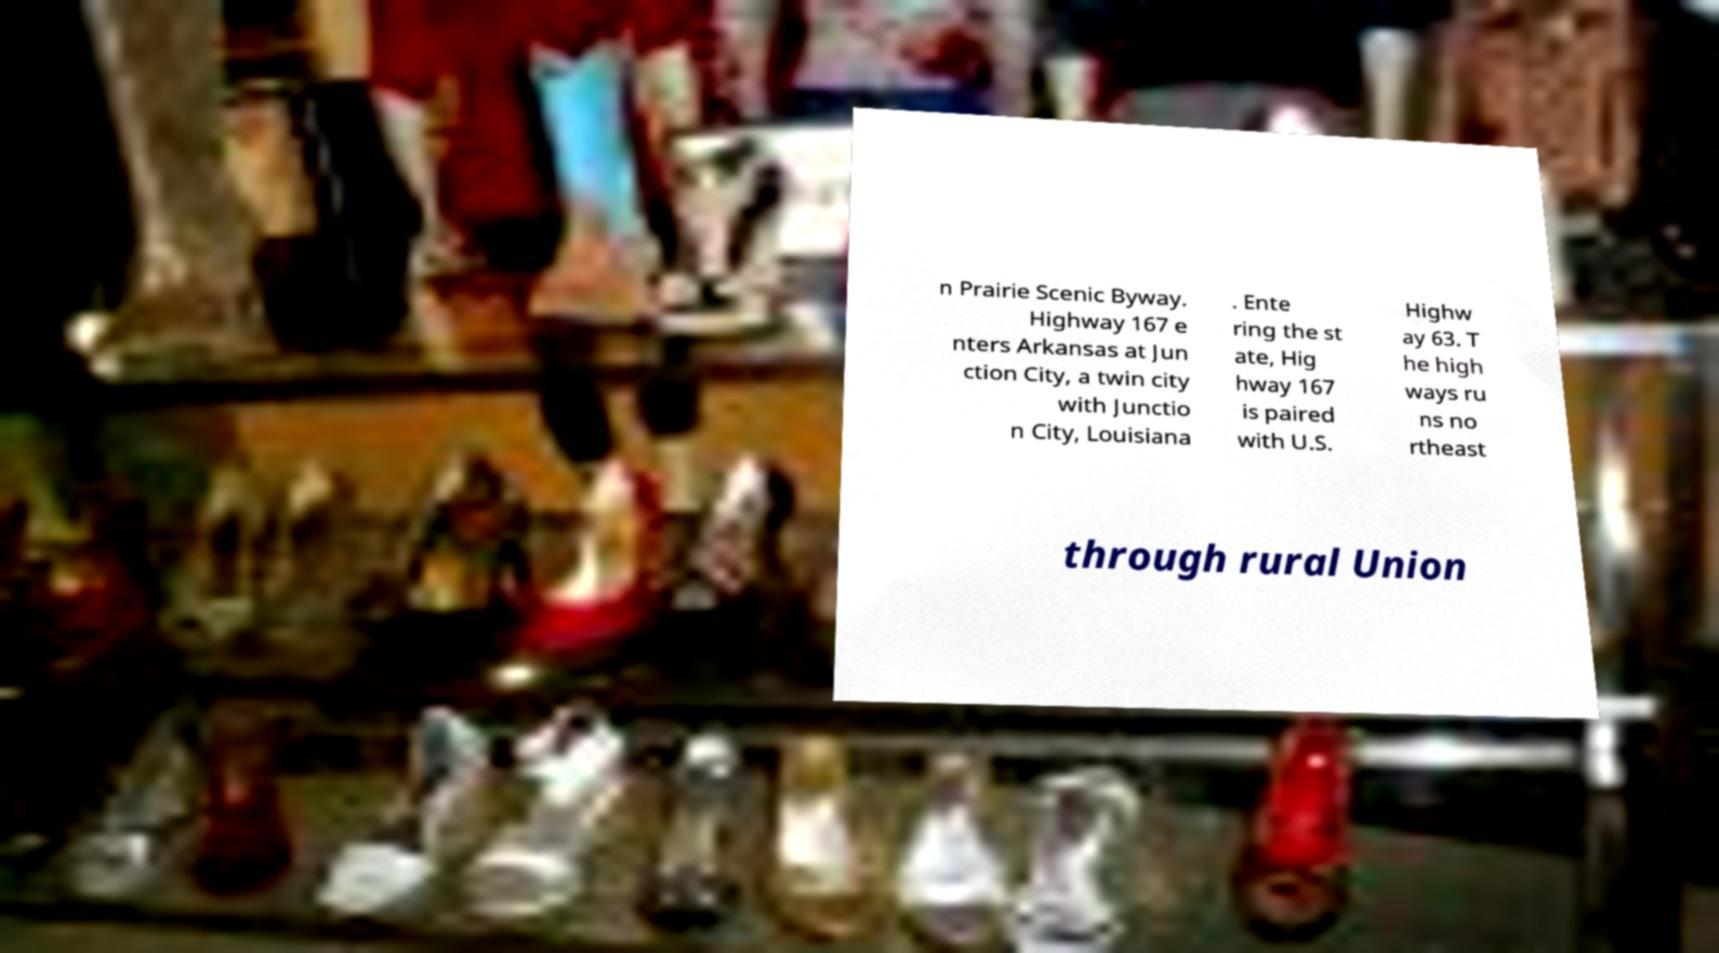Please identify and transcribe the text found in this image. n Prairie Scenic Byway. Highway 167 e nters Arkansas at Jun ction City, a twin city with Junctio n City, Louisiana . Ente ring the st ate, Hig hway 167 is paired with U.S. Highw ay 63. T he high ways ru ns no rtheast through rural Union 